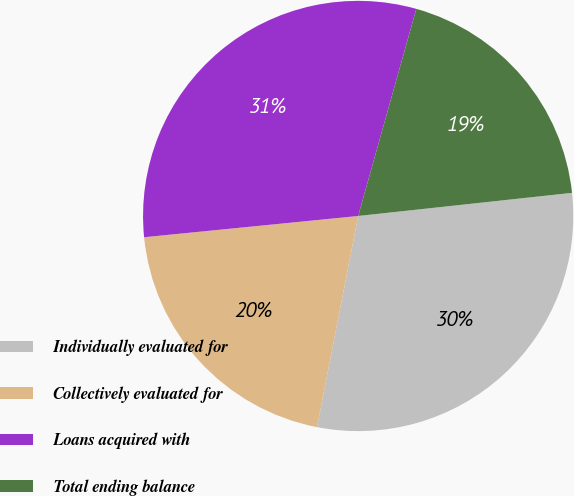<chart> <loc_0><loc_0><loc_500><loc_500><pie_chart><fcel>Individually evaluated for<fcel>Collectively evaluated for<fcel>Loans acquired with<fcel>Total ending balance<nl><fcel>29.78%<fcel>20.36%<fcel>30.93%<fcel>18.93%<nl></chart> 